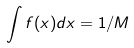<formula> <loc_0><loc_0><loc_500><loc_500>\int f ( x ) d x = 1 / M</formula> 